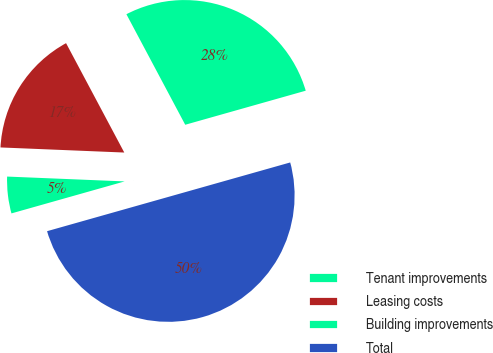Convert chart. <chart><loc_0><loc_0><loc_500><loc_500><pie_chart><fcel>Tenant improvements<fcel>Leasing costs<fcel>Building improvements<fcel>Total<nl><fcel>28.4%<fcel>16.56%<fcel>5.04%<fcel>50.0%<nl></chart> 